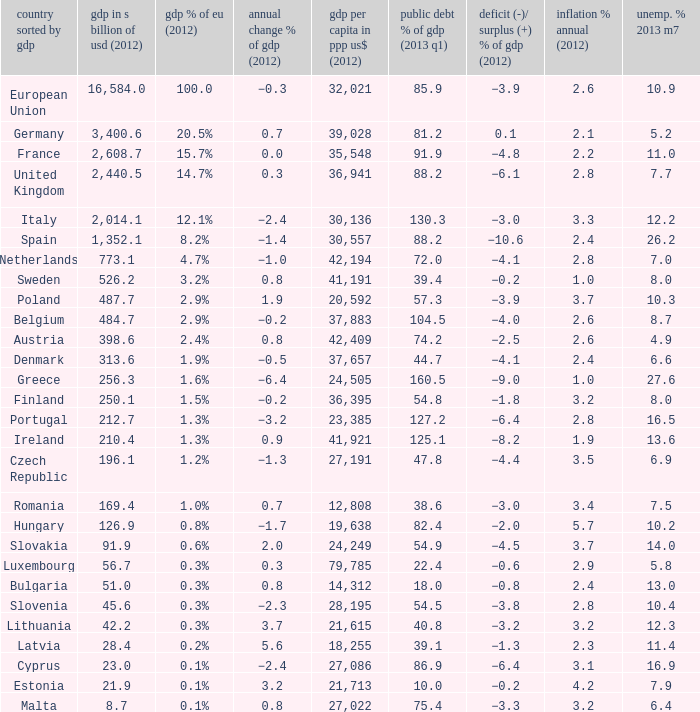What is the largest inflation % annual in 2012 of the country with a public debt % of GDP in 2013 Q1 greater than 88.2 and a GDP % of EU in 2012 of 2.9%? 2.6. 